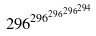<formula> <loc_0><loc_0><loc_500><loc_500>2 9 6 ^ { 2 9 6 ^ { 2 9 6 ^ { 2 9 6 ^ { 2 9 4 } } } }</formula> 